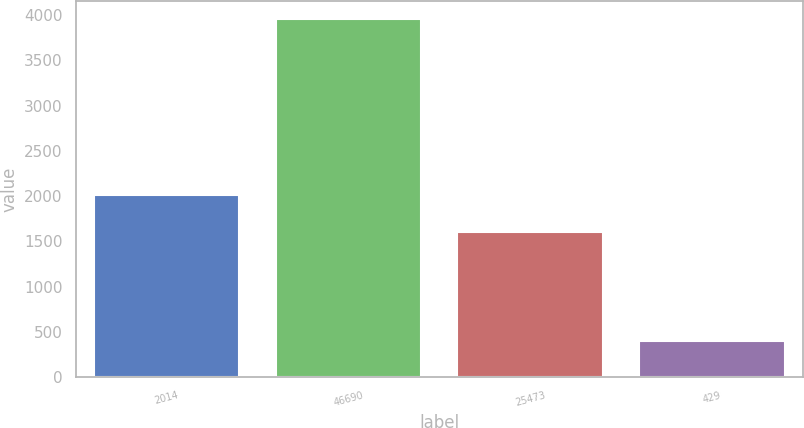Convert chart. <chart><loc_0><loc_0><loc_500><loc_500><bar_chart><fcel>2014<fcel>46690<fcel>25473<fcel>429<nl><fcel>2012<fcel>3960.9<fcel>1607.4<fcel>396.6<nl></chart> 